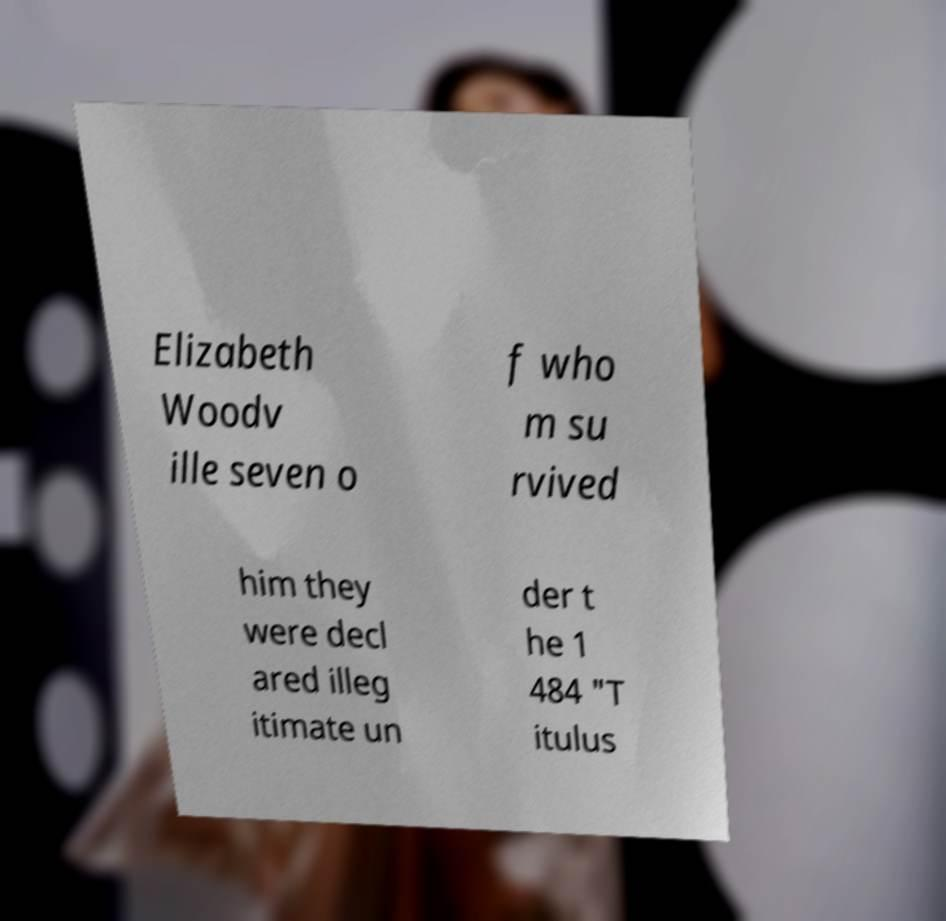Could you extract and type out the text from this image? Elizabeth Woodv ille seven o f who m su rvived him they were decl ared illeg itimate un der t he 1 484 "T itulus 